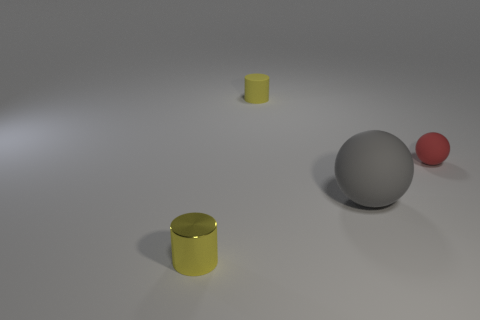If this were a scene from a film, what genre do you think it would fit best in? The minimalistic and clean setting, with prominently displayed geometric shapes, could lend itself to a science fiction genre. The simplicity and the focus on form could also align with an artistic experimental film, where the focus is on the aesthetic and visual composition rather than narrative. 